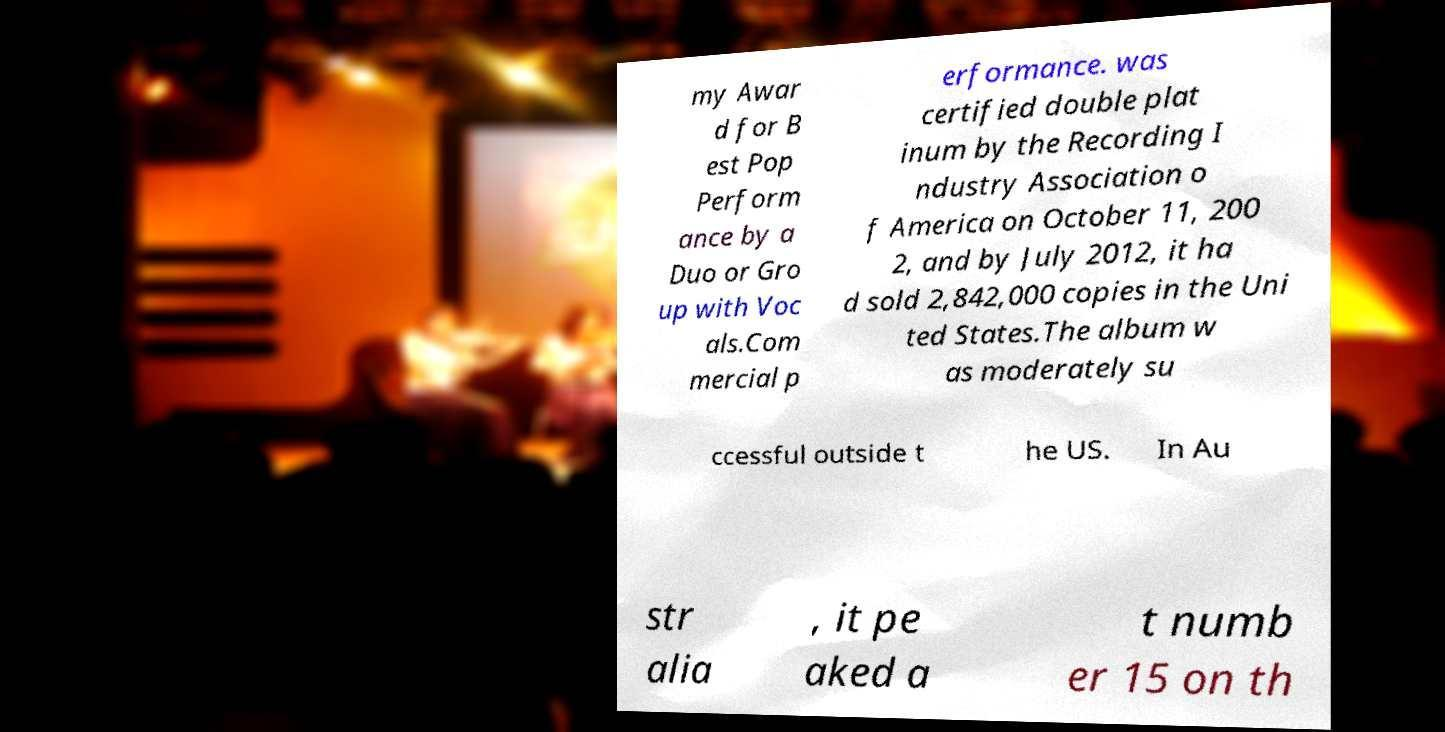For documentation purposes, I need the text within this image transcribed. Could you provide that? my Awar d for B est Pop Perform ance by a Duo or Gro up with Voc als.Com mercial p erformance. was certified double plat inum by the Recording I ndustry Association o f America on October 11, 200 2, and by July 2012, it ha d sold 2,842,000 copies in the Uni ted States.The album w as moderately su ccessful outside t he US. In Au str alia , it pe aked a t numb er 15 on th 